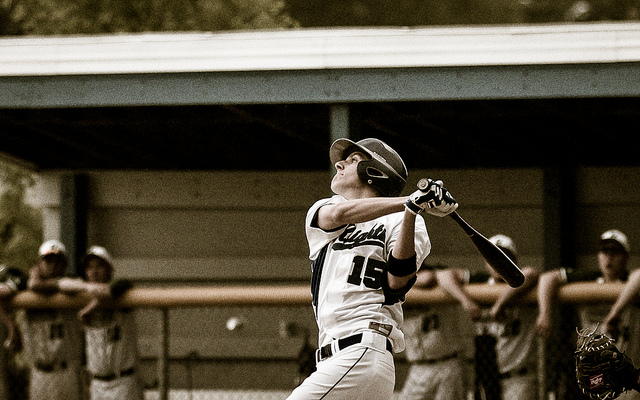Please identify all text content in this image. 15 